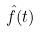Convert formula to latex. <formula><loc_0><loc_0><loc_500><loc_500>\hat { f } ( t )</formula> 